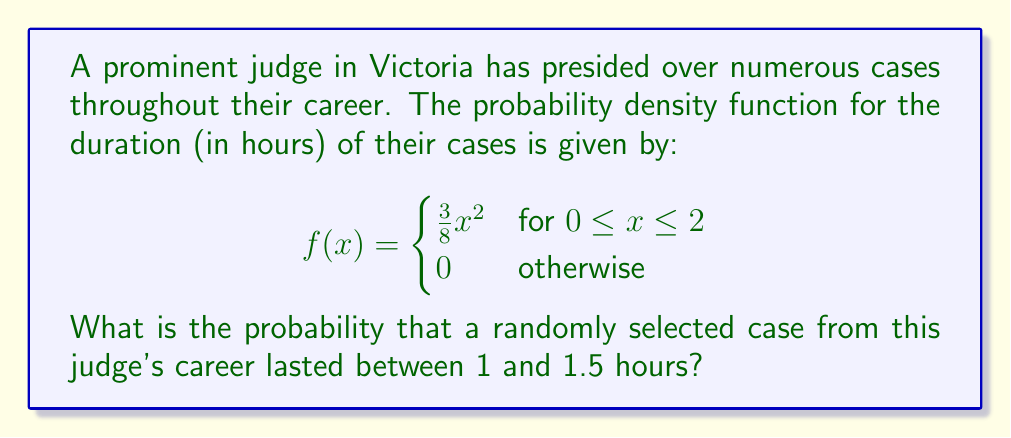Can you solve this math problem? To find the probability that a case lasted between 1 and 1.5 hours, we need to integrate the probability density function over this interval:

$$P(1 \leq X \leq 1.5) = \int_{1}^{1.5} f(x) dx$$

Step 1: Substitute the given function into the integral.
$$P(1 \leq X \leq 1.5) = \int_{1}^{1.5} \frac{3}{8}x^2 dx$$

Step 2: Integrate the function.
$$P(1 \leq X \leq 1.5) = \frac{3}{8} \int_{1}^{1.5} x^2 dx = \frac{3}{8} \left[\frac{x^3}{3}\right]_{1}^{1.5}$$

Step 3: Evaluate the integral at the limits.
$$P(1 \leq X \leq 1.5) = \frac{3}{8} \left(\frac{(1.5)^3}{3} - \frac{1^3}{3}\right)$$

Step 4: Simplify the expression.
$$P(1 \leq X \leq 1.5) = \frac{3}{8} \left(\frac{3.375}{3} - \frac{1}{3}\right) = \frac{3}{8} \cdot \frac{2.375}{3} = \frac{2.375}{8} = 0.296875$$

Therefore, the probability that a randomly selected case from this judge's career lasted between 1 and 1.5 hours is approximately 0.296875 or 29.69%.
Answer: 0.296875 